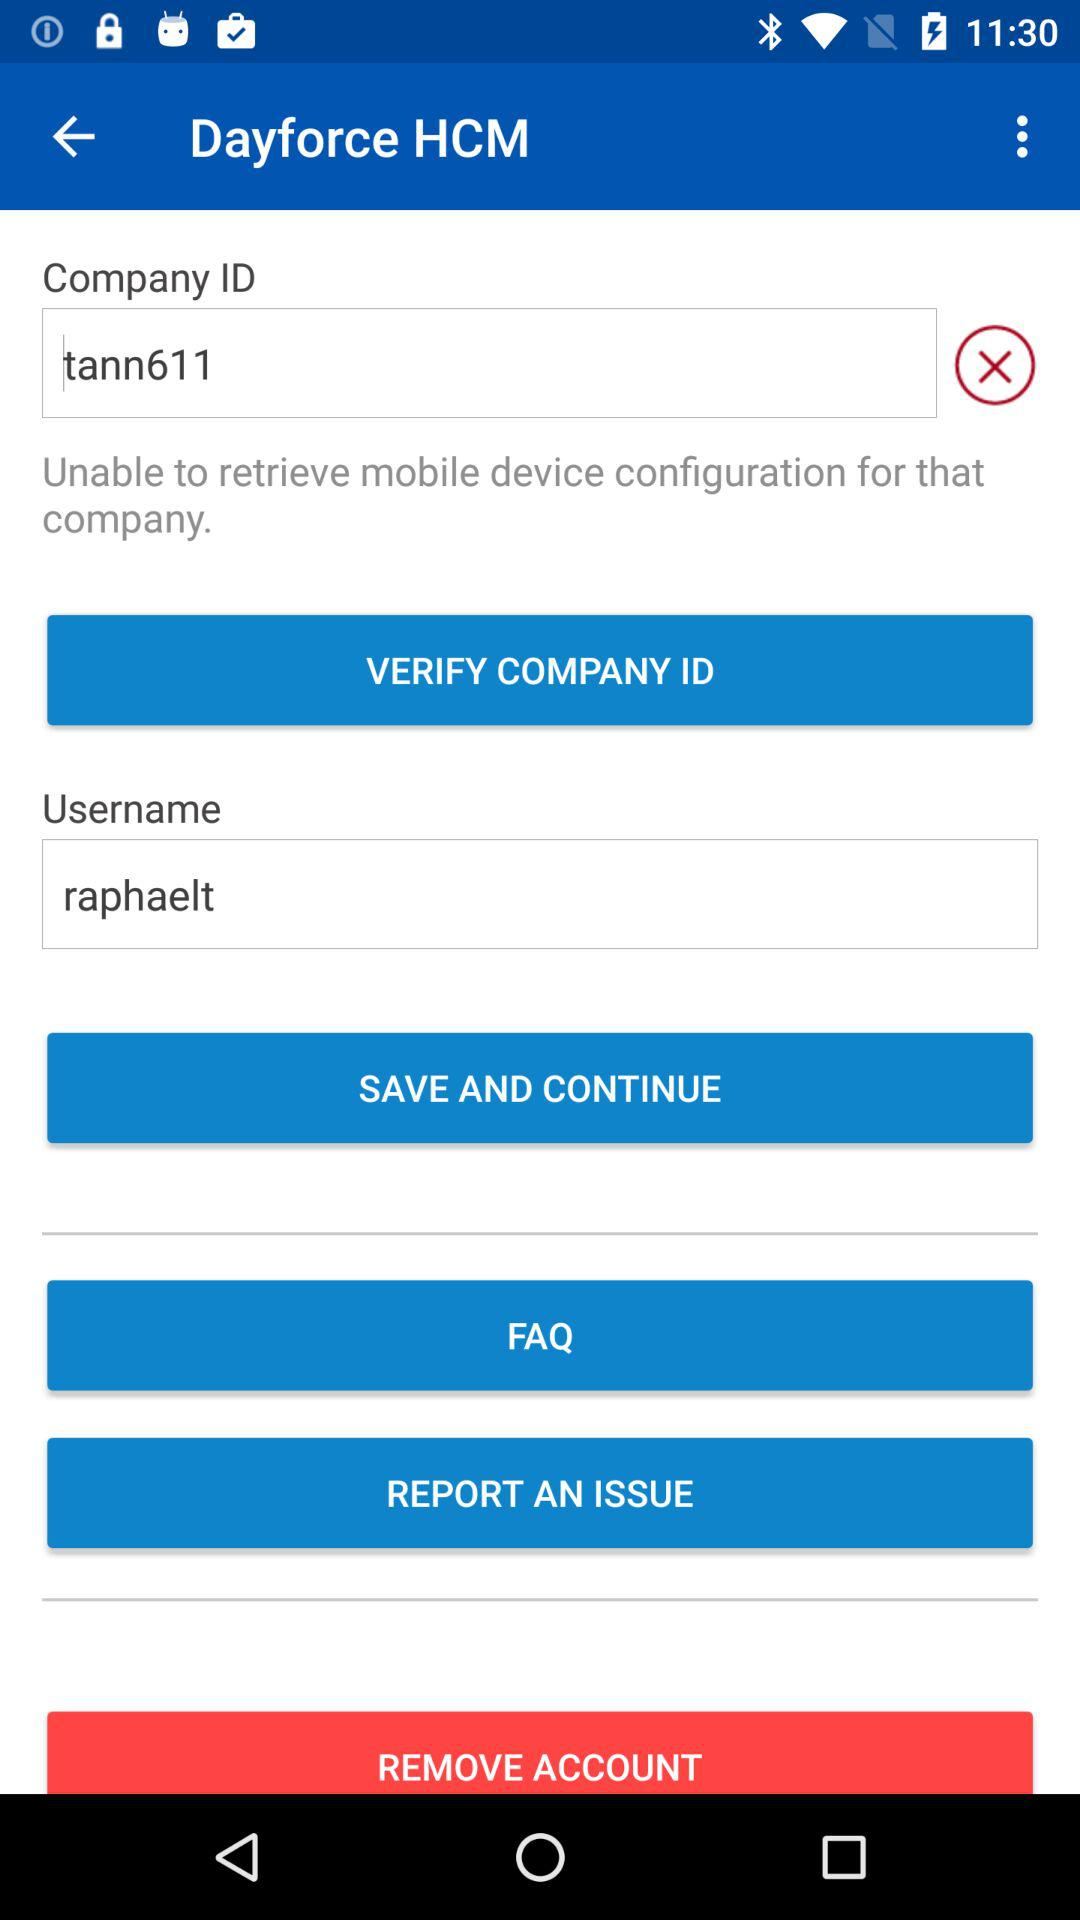What is the company ID? The company ID is tann611. 